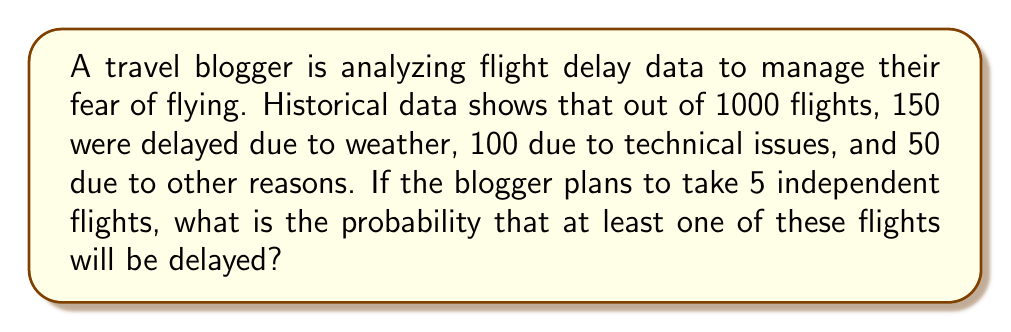What is the answer to this math problem? Let's approach this step-by-step:

1) First, let's calculate the probability of a single flight being delayed:

   Total delayed flights = 150 + 100 + 50 = 300
   Probability of delay = $\frac{300}{1000} = 0.3$ or 30%

2) Now, let's calculate the probability of a flight not being delayed:

   Probability of no delay = 1 - 0.3 = 0.7 or 70%

3) For 5 independent flights, the probability that all flights are on time is:

   $P(\text{all on time}) = 0.7^5 = 0.16807$

4) Therefore, the probability that at least one flight is delayed is the complement of all flights being on time:

   $P(\text{at least one delayed}) = 1 - P(\text{all on time})$
   $= 1 - 0.16807 = 0.83193$

5) Converting to a percentage:

   0.83193 * 100 = 83.193%

This means there's approximately an 83.2% chance that at least one of the five flights will be delayed.
Answer: 83.2% 